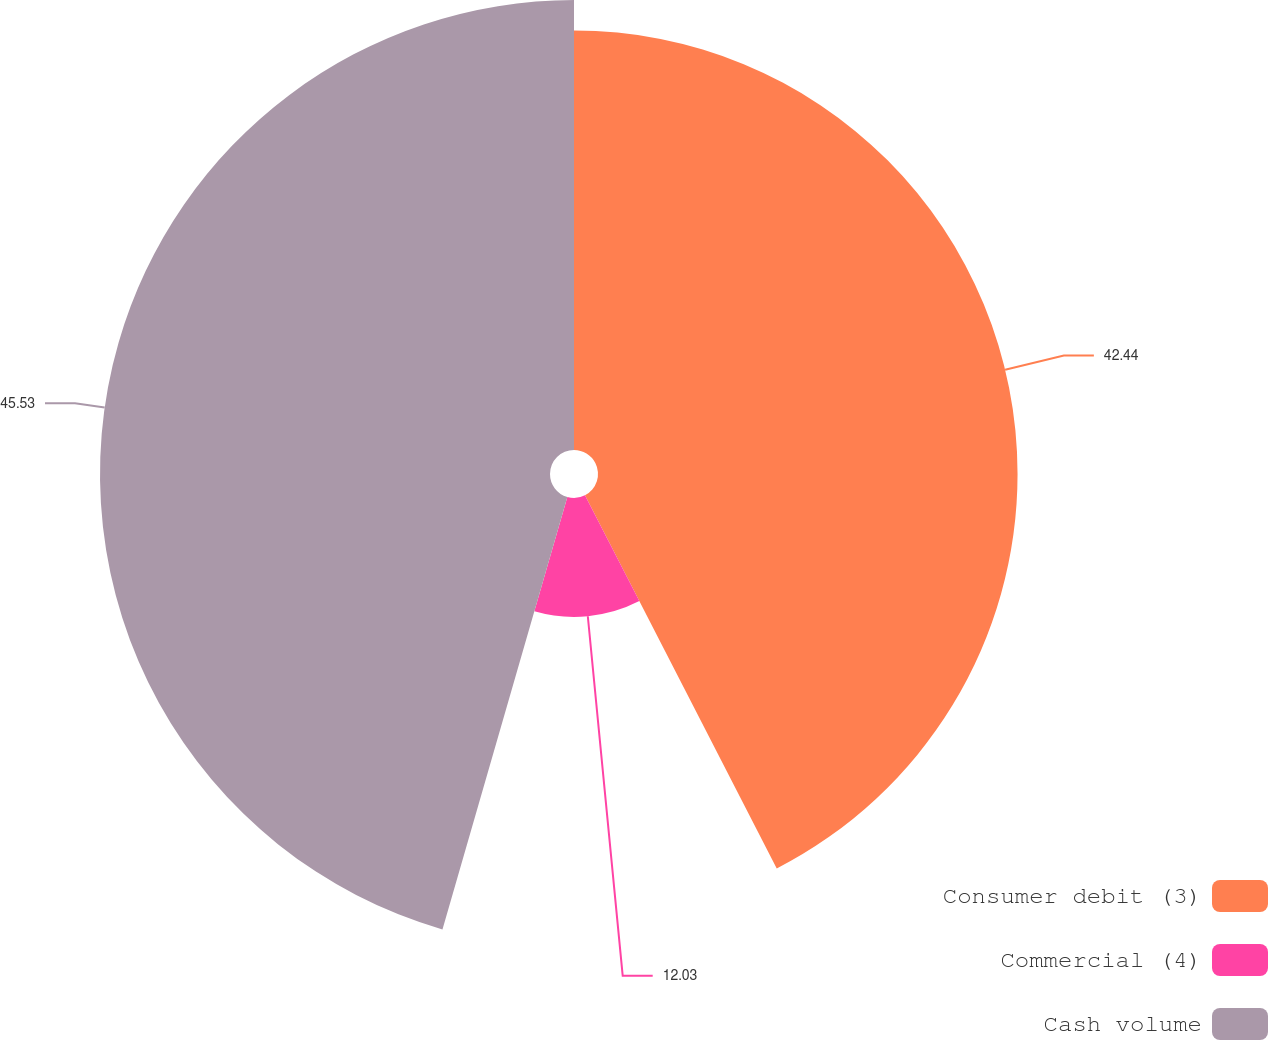<chart> <loc_0><loc_0><loc_500><loc_500><pie_chart><fcel>Consumer debit (3)<fcel>Commercial (4)<fcel>Cash volume<nl><fcel>42.44%<fcel>12.03%<fcel>45.52%<nl></chart> 